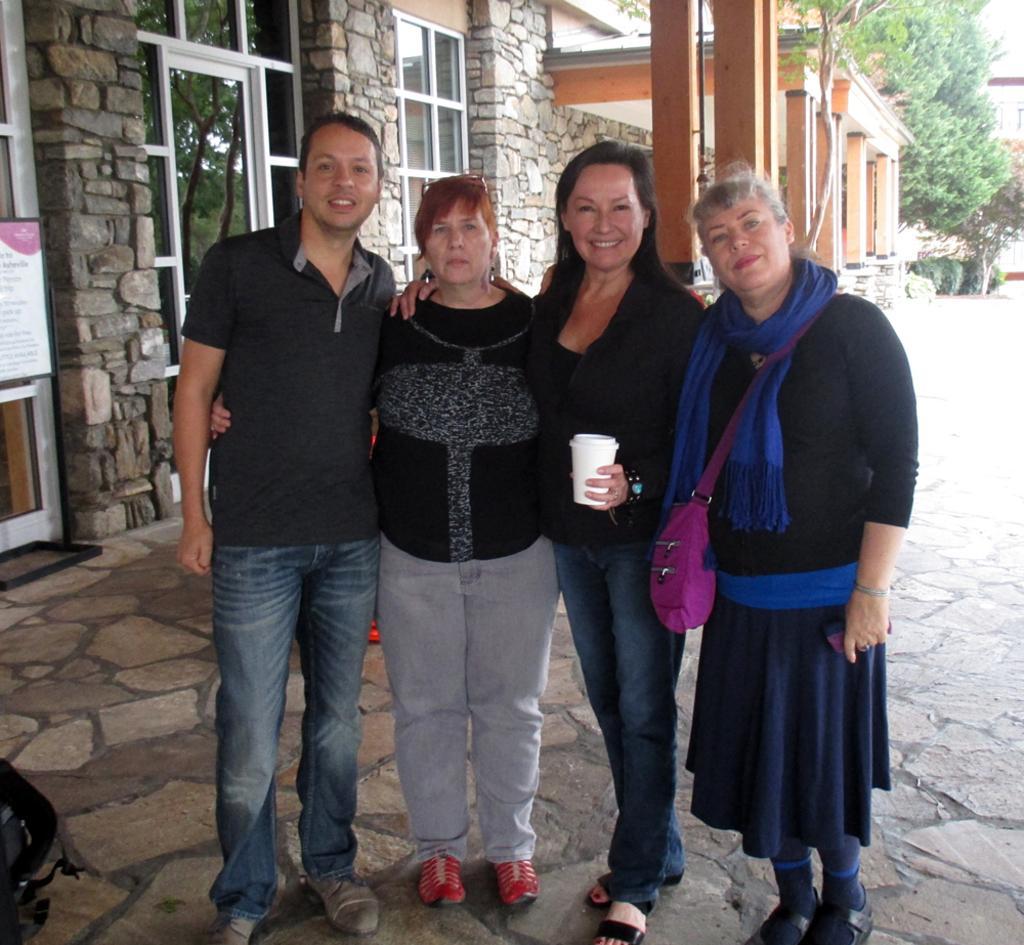In one or two sentences, can you explain what this image depicts? In this picture we can see a group of people standing on the ground and in the background we can see buildings,trees. 